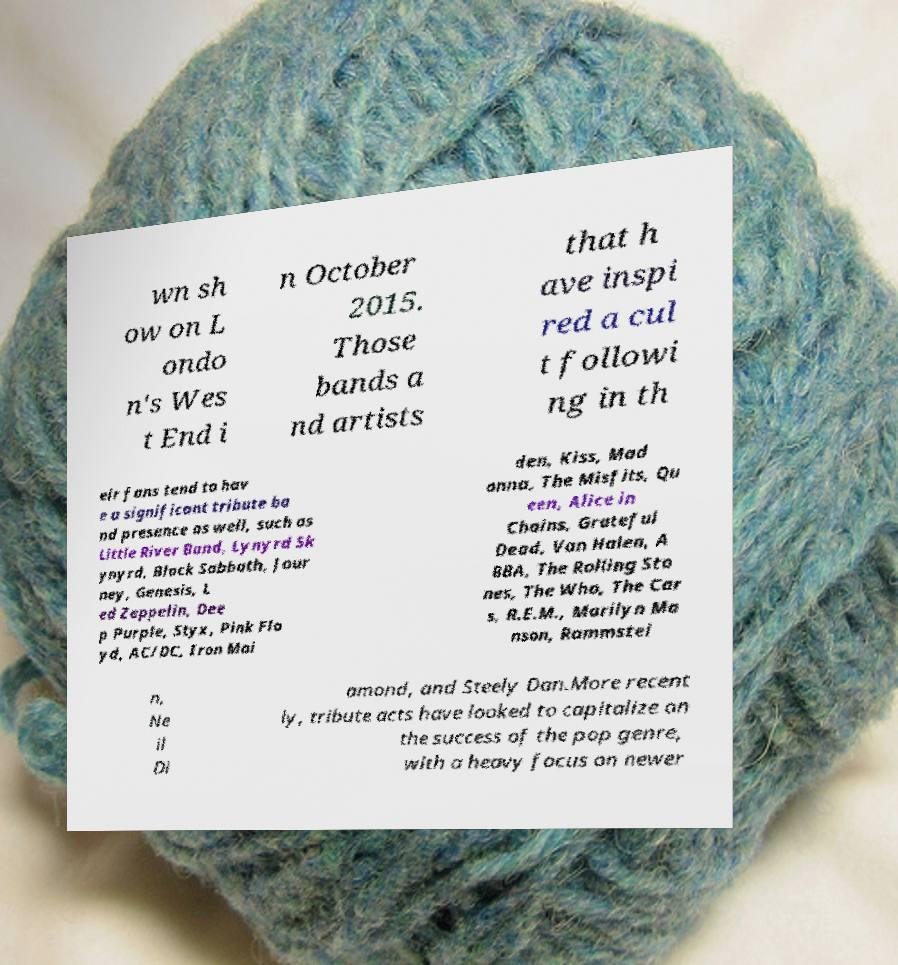Could you extract and type out the text from this image? wn sh ow on L ondo n's Wes t End i n October 2015. Those bands a nd artists that h ave inspi red a cul t followi ng in th eir fans tend to hav e a significant tribute ba nd presence as well, such as Little River Band, Lynyrd Sk ynyrd, Black Sabbath, Jour ney, Genesis, L ed Zeppelin, Dee p Purple, Styx, Pink Flo yd, AC/DC, Iron Mai den, Kiss, Mad onna, The Misfits, Qu een, Alice in Chains, Grateful Dead, Van Halen, A BBA, The Rolling Sto nes, The Who, The Car s, R.E.M., Marilyn Ma nson, Rammstei n, Ne il Di amond, and Steely Dan.More recent ly, tribute acts have looked to capitalize on the success of the pop genre, with a heavy focus on newer 